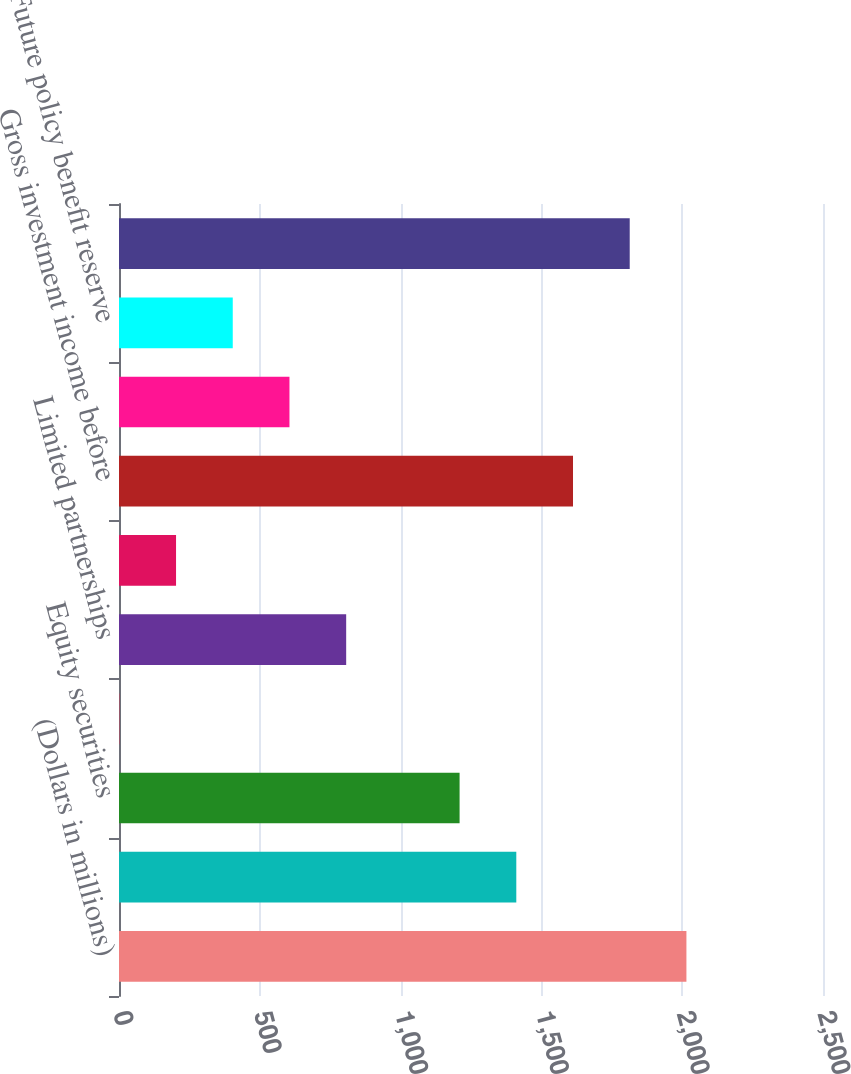Convert chart to OTSL. <chart><loc_0><loc_0><loc_500><loc_500><bar_chart><fcel>(Dollars in millions)<fcel>Fixed maturities<fcel>Equity securities<fcel>Short-term investments and<fcel>Limited partnerships<fcel>Other<fcel>Gross investment income before<fcel>Funds held interest income<fcel>Future policy benefit reserve<fcel>Gross investment income<nl><fcel>2015<fcel>1410.86<fcel>1209.48<fcel>1.2<fcel>806.72<fcel>202.58<fcel>1612.24<fcel>605.34<fcel>403.96<fcel>1813.62<nl></chart> 